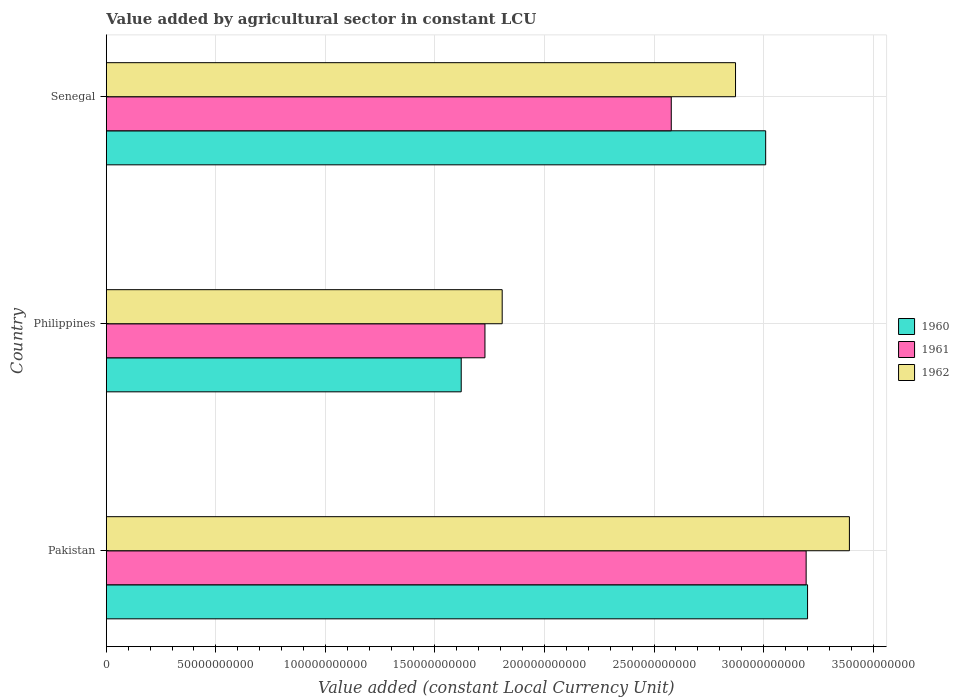How many groups of bars are there?
Your answer should be very brief. 3. Are the number of bars on each tick of the Y-axis equal?
Your answer should be compact. Yes. What is the label of the 3rd group of bars from the top?
Your answer should be compact. Pakistan. In how many cases, is the number of bars for a given country not equal to the number of legend labels?
Your answer should be compact. 0. What is the value added by agricultural sector in 1961 in Philippines?
Ensure brevity in your answer.  1.73e+11. Across all countries, what is the maximum value added by agricultural sector in 1960?
Provide a succinct answer. 3.20e+11. Across all countries, what is the minimum value added by agricultural sector in 1960?
Your answer should be compact. 1.62e+11. What is the total value added by agricultural sector in 1960 in the graph?
Keep it short and to the point. 7.83e+11. What is the difference between the value added by agricultural sector in 1960 in Pakistan and that in Philippines?
Make the answer very short. 1.58e+11. What is the difference between the value added by agricultural sector in 1961 in Pakistan and the value added by agricultural sector in 1960 in Senegal?
Provide a short and direct response. 1.85e+1. What is the average value added by agricultural sector in 1961 per country?
Offer a very short reply. 2.50e+11. What is the difference between the value added by agricultural sector in 1960 and value added by agricultural sector in 1962 in Pakistan?
Provide a succinct answer. -1.91e+1. What is the ratio of the value added by agricultural sector in 1962 in Pakistan to that in Philippines?
Provide a succinct answer. 1.88. Is the value added by agricultural sector in 1962 in Philippines less than that in Senegal?
Offer a terse response. Yes. Is the difference between the value added by agricultural sector in 1960 in Philippines and Senegal greater than the difference between the value added by agricultural sector in 1962 in Philippines and Senegal?
Offer a terse response. No. What is the difference between the highest and the second highest value added by agricultural sector in 1962?
Keep it short and to the point. 5.20e+1. What is the difference between the highest and the lowest value added by agricultural sector in 1962?
Offer a terse response. 1.58e+11. Is the sum of the value added by agricultural sector in 1961 in Pakistan and Senegal greater than the maximum value added by agricultural sector in 1960 across all countries?
Your response must be concise. Yes. What does the 2nd bar from the top in Pakistan represents?
Offer a very short reply. 1961. Is it the case that in every country, the sum of the value added by agricultural sector in 1960 and value added by agricultural sector in 1961 is greater than the value added by agricultural sector in 1962?
Your answer should be very brief. Yes. Are all the bars in the graph horizontal?
Your answer should be compact. Yes. How many countries are there in the graph?
Give a very brief answer. 3. Are the values on the major ticks of X-axis written in scientific E-notation?
Ensure brevity in your answer.  No. Where does the legend appear in the graph?
Give a very brief answer. Center right. How are the legend labels stacked?
Your answer should be compact. Vertical. What is the title of the graph?
Your answer should be very brief. Value added by agricultural sector in constant LCU. What is the label or title of the X-axis?
Keep it short and to the point. Value added (constant Local Currency Unit). What is the Value added (constant Local Currency Unit) of 1960 in Pakistan?
Ensure brevity in your answer.  3.20e+11. What is the Value added (constant Local Currency Unit) of 1961 in Pakistan?
Provide a short and direct response. 3.19e+11. What is the Value added (constant Local Currency Unit) in 1962 in Pakistan?
Provide a short and direct response. 3.39e+11. What is the Value added (constant Local Currency Unit) in 1960 in Philippines?
Ensure brevity in your answer.  1.62e+11. What is the Value added (constant Local Currency Unit) of 1961 in Philippines?
Offer a very short reply. 1.73e+11. What is the Value added (constant Local Currency Unit) in 1962 in Philippines?
Offer a very short reply. 1.81e+11. What is the Value added (constant Local Currency Unit) in 1960 in Senegal?
Your response must be concise. 3.01e+11. What is the Value added (constant Local Currency Unit) of 1961 in Senegal?
Provide a succinct answer. 2.58e+11. What is the Value added (constant Local Currency Unit) in 1962 in Senegal?
Your response must be concise. 2.87e+11. Across all countries, what is the maximum Value added (constant Local Currency Unit) of 1960?
Ensure brevity in your answer.  3.20e+11. Across all countries, what is the maximum Value added (constant Local Currency Unit) in 1961?
Your response must be concise. 3.19e+11. Across all countries, what is the maximum Value added (constant Local Currency Unit) of 1962?
Offer a very short reply. 3.39e+11. Across all countries, what is the minimum Value added (constant Local Currency Unit) in 1960?
Keep it short and to the point. 1.62e+11. Across all countries, what is the minimum Value added (constant Local Currency Unit) in 1961?
Offer a very short reply. 1.73e+11. Across all countries, what is the minimum Value added (constant Local Currency Unit) in 1962?
Offer a very short reply. 1.81e+11. What is the total Value added (constant Local Currency Unit) in 1960 in the graph?
Provide a short and direct response. 7.83e+11. What is the total Value added (constant Local Currency Unit) of 1961 in the graph?
Offer a terse response. 7.50e+11. What is the total Value added (constant Local Currency Unit) of 1962 in the graph?
Provide a short and direct response. 8.07e+11. What is the difference between the Value added (constant Local Currency Unit) in 1960 in Pakistan and that in Philippines?
Make the answer very short. 1.58e+11. What is the difference between the Value added (constant Local Currency Unit) in 1961 in Pakistan and that in Philippines?
Give a very brief answer. 1.47e+11. What is the difference between the Value added (constant Local Currency Unit) of 1962 in Pakistan and that in Philippines?
Provide a succinct answer. 1.58e+11. What is the difference between the Value added (constant Local Currency Unit) in 1960 in Pakistan and that in Senegal?
Offer a terse response. 1.91e+1. What is the difference between the Value added (constant Local Currency Unit) in 1961 in Pakistan and that in Senegal?
Keep it short and to the point. 6.16e+1. What is the difference between the Value added (constant Local Currency Unit) in 1962 in Pakistan and that in Senegal?
Your answer should be compact. 5.20e+1. What is the difference between the Value added (constant Local Currency Unit) in 1960 in Philippines and that in Senegal?
Your response must be concise. -1.39e+11. What is the difference between the Value added (constant Local Currency Unit) of 1961 in Philippines and that in Senegal?
Your response must be concise. -8.50e+1. What is the difference between the Value added (constant Local Currency Unit) in 1962 in Philippines and that in Senegal?
Provide a succinct answer. -1.07e+11. What is the difference between the Value added (constant Local Currency Unit) of 1960 in Pakistan and the Value added (constant Local Currency Unit) of 1961 in Philippines?
Your response must be concise. 1.47e+11. What is the difference between the Value added (constant Local Currency Unit) of 1960 in Pakistan and the Value added (constant Local Currency Unit) of 1962 in Philippines?
Your answer should be very brief. 1.39e+11. What is the difference between the Value added (constant Local Currency Unit) of 1961 in Pakistan and the Value added (constant Local Currency Unit) of 1962 in Philippines?
Offer a terse response. 1.39e+11. What is the difference between the Value added (constant Local Currency Unit) in 1960 in Pakistan and the Value added (constant Local Currency Unit) in 1961 in Senegal?
Keep it short and to the point. 6.22e+1. What is the difference between the Value added (constant Local Currency Unit) of 1960 in Pakistan and the Value added (constant Local Currency Unit) of 1962 in Senegal?
Make the answer very short. 3.29e+1. What is the difference between the Value added (constant Local Currency Unit) of 1961 in Pakistan and the Value added (constant Local Currency Unit) of 1962 in Senegal?
Your answer should be compact. 3.22e+1. What is the difference between the Value added (constant Local Currency Unit) in 1960 in Philippines and the Value added (constant Local Currency Unit) in 1961 in Senegal?
Your answer should be compact. -9.59e+1. What is the difference between the Value added (constant Local Currency Unit) in 1960 in Philippines and the Value added (constant Local Currency Unit) in 1962 in Senegal?
Offer a very short reply. -1.25e+11. What is the difference between the Value added (constant Local Currency Unit) of 1961 in Philippines and the Value added (constant Local Currency Unit) of 1962 in Senegal?
Provide a succinct answer. -1.14e+11. What is the average Value added (constant Local Currency Unit) of 1960 per country?
Offer a very short reply. 2.61e+11. What is the average Value added (constant Local Currency Unit) of 1961 per country?
Offer a terse response. 2.50e+11. What is the average Value added (constant Local Currency Unit) of 1962 per country?
Offer a very short reply. 2.69e+11. What is the difference between the Value added (constant Local Currency Unit) of 1960 and Value added (constant Local Currency Unit) of 1961 in Pakistan?
Offer a very short reply. 6.46e+08. What is the difference between the Value added (constant Local Currency Unit) of 1960 and Value added (constant Local Currency Unit) of 1962 in Pakistan?
Provide a succinct answer. -1.91e+1. What is the difference between the Value added (constant Local Currency Unit) of 1961 and Value added (constant Local Currency Unit) of 1962 in Pakistan?
Offer a terse response. -1.97e+1. What is the difference between the Value added (constant Local Currency Unit) of 1960 and Value added (constant Local Currency Unit) of 1961 in Philippines?
Your answer should be compact. -1.08e+1. What is the difference between the Value added (constant Local Currency Unit) of 1960 and Value added (constant Local Currency Unit) of 1962 in Philippines?
Your answer should be very brief. -1.87e+1. What is the difference between the Value added (constant Local Currency Unit) in 1961 and Value added (constant Local Currency Unit) in 1962 in Philippines?
Provide a succinct answer. -7.86e+09. What is the difference between the Value added (constant Local Currency Unit) in 1960 and Value added (constant Local Currency Unit) in 1961 in Senegal?
Your response must be concise. 4.31e+1. What is the difference between the Value added (constant Local Currency Unit) of 1960 and Value added (constant Local Currency Unit) of 1962 in Senegal?
Make the answer very short. 1.38e+1. What is the difference between the Value added (constant Local Currency Unit) of 1961 and Value added (constant Local Currency Unit) of 1962 in Senegal?
Your answer should be compact. -2.93e+1. What is the ratio of the Value added (constant Local Currency Unit) of 1960 in Pakistan to that in Philippines?
Keep it short and to the point. 1.98. What is the ratio of the Value added (constant Local Currency Unit) in 1961 in Pakistan to that in Philippines?
Ensure brevity in your answer.  1.85. What is the ratio of the Value added (constant Local Currency Unit) in 1962 in Pakistan to that in Philippines?
Ensure brevity in your answer.  1.88. What is the ratio of the Value added (constant Local Currency Unit) in 1960 in Pakistan to that in Senegal?
Your response must be concise. 1.06. What is the ratio of the Value added (constant Local Currency Unit) of 1961 in Pakistan to that in Senegal?
Your answer should be very brief. 1.24. What is the ratio of the Value added (constant Local Currency Unit) in 1962 in Pakistan to that in Senegal?
Your answer should be very brief. 1.18. What is the ratio of the Value added (constant Local Currency Unit) of 1960 in Philippines to that in Senegal?
Make the answer very short. 0.54. What is the ratio of the Value added (constant Local Currency Unit) of 1961 in Philippines to that in Senegal?
Your answer should be very brief. 0.67. What is the ratio of the Value added (constant Local Currency Unit) in 1962 in Philippines to that in Senegal?
Ensure brevity in your answer.  0.63. What is the difference between the highest and the second highest Value added (constant Local Currency Unit) of 1960?
Provide a succinct answer. 1.91e+1. What is the difference between the highest and the second highest Value added (constant Local Currency Unit) of 1961?
Provide a succinct answer. 6.16e+1. What is the difference between the highest and the second highest Value added (constant Local Currency Unit) in 1962?
Provide a short and direct response. 5.20e+1. What is the difference between the highest and the lowest Value added (constant Local Currency Unit) of 1960?
Your response must be concise. 1.58e+11. What is the difference between the highest and the lowest Value added (constant Local Currency Unit) in 1961?
Ensure brevity in your answer.  1.47e+11. What is the difference between the highest and the lowest Value added (constant Local Currency Unit) in 1962?
Your answer should be very brief. 1.58e+11. 